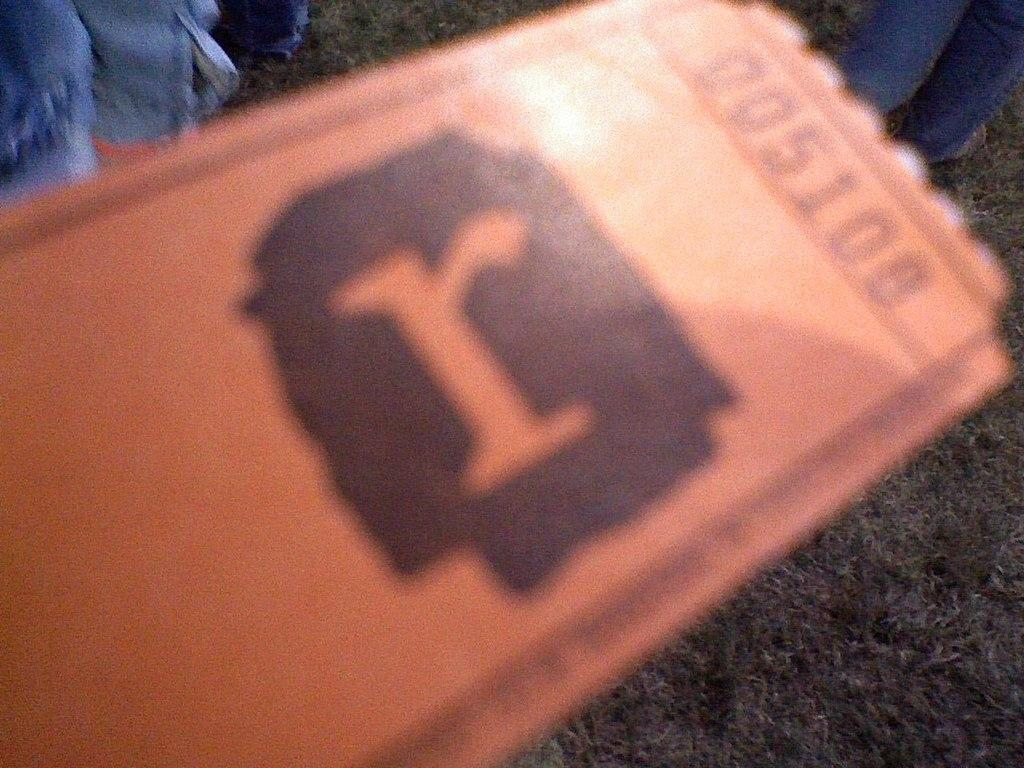What type of item is depicted in the image? The image appears to be a ticket. Can you describe any additional elements in the image? There is a person standing in the top right corner of the image. What type of toys can be seen in the image? There are no toys present in the image. How does the person in the image express disgust? There is no indication of the person's emotions or expressions in the image. 